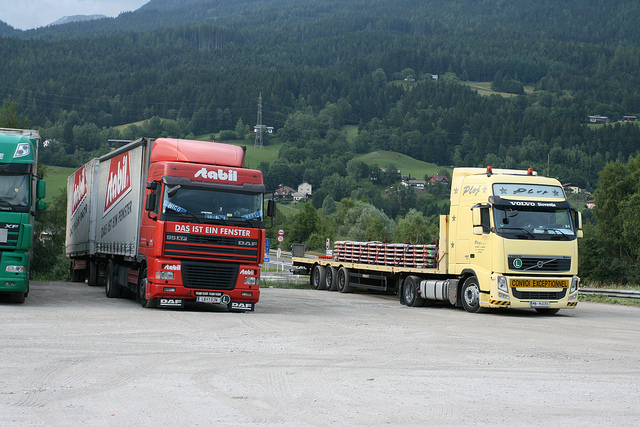Extract all visible text content from this image. Aabil DAS IST EIN FENSTER DAE L Exceptional VOLVO Plot 